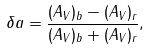<formula> <loc_0><loc_0><loc_500><loc_500>\delta a = \frac { ( A _ { V } ) _ { b } - ( A _ { V } ) _ { r } } { ( A _ { V } ) _ { b } + ( A _ { V } ) _ { r } } ,</formula> 